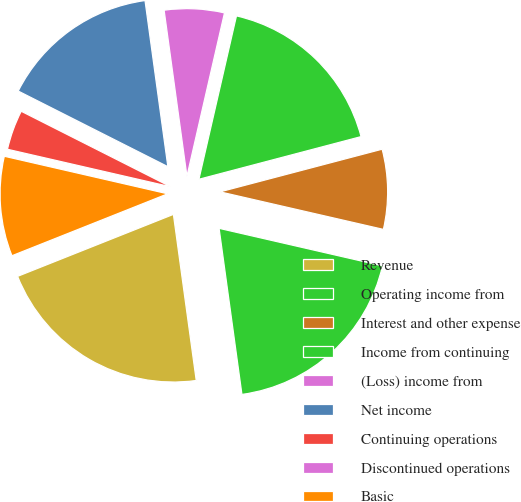Convert chart. <chart><loc_0><loc_0><loc_500><loc_500><pie_chart><fcel>Revenue<fcel>Operating income from<fcel>Interest and other expense<fcel>Income from continuing<fcel>(Loss) income from<fcel>Net income<fcel>Continuing operations<fcel>Discontinued operations<fcel>Basic<nl><fcel>21.15%<fcel>19.23%<fcel>7.69%<fcel>17.31%<fcel>5.77%<fcel>15.38%<fcel>3.85%<fcel>0.0%<fcel>9.62%<nl></chart> 